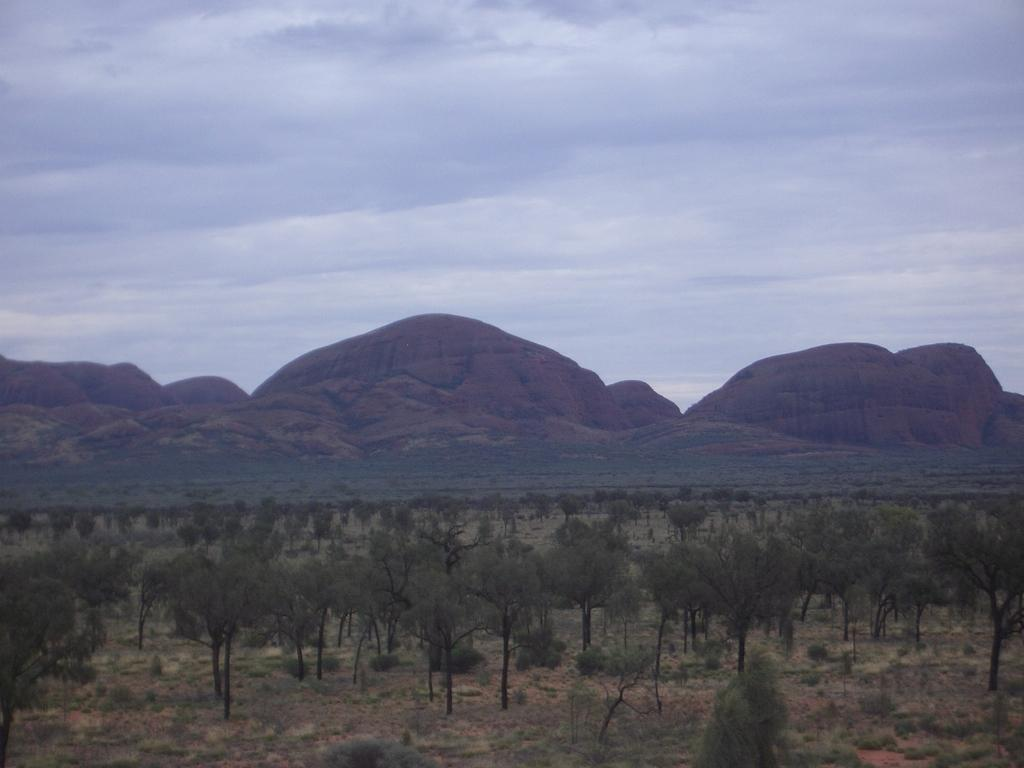What type of natural formation can be seen in the image? There are mountains in the image. What other natural elements are present in the image? There are trees and mud visible in the image. What is visible at the top of the image? The sky is visible at the top of the image. What can be seen in the sky? There are clouds in the sky. Can you tell me how many shades of green can be seen in the trees? The image does not provide information about the number of shades of green in the trees. Is there a bridge visible in the image? There is no bridge present in the image. 